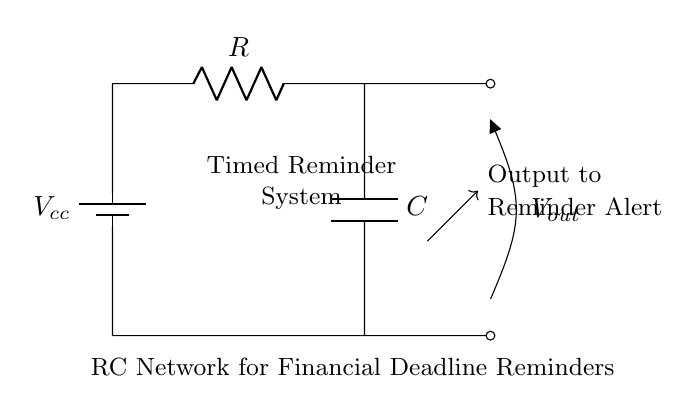What is the function of the capacitor in this circuit? The capacitor stores charge and affects the timing of the reminder system. It charges through the resistor and discharges to generate an output signal after a certain time delay.
Answer: timing What type of circuit is shown here? The circuit is a series circuit, as all components (battery, resistor, and capacitor) are connected in a single loop. Current flows through each component sequentially.
Answer: series What does the output voltage represent? The output voltage is the voltage across the capacitor, which changes as it charges and discharges, triggering the reminder alert when it reaches a certain level.
Answer: reminder alert voltage What is the purpose of the resistor in this circuit? The resistor limits the current flow to the capacitor, controlling the rate at which it charges and thus affecting the timing interval for the reminder system.
Answer: current limitation How is the reminder triggered in this circuit? The reminder is triggered when the voltage across the capacitor reaches a predetermined threshold, which is determined by the values of the resistor and capacitor.
Answer: voltage threshold What indicates the system is operational? The indicator is the presence of an output voltage signal that will alert the user when the reminder event occurs after the capacitor has charged sufficiently.
Answer: output voltage signal What component stores energy in the circuit? The capacitor is the component that stores electrical energy in the circuit, enabling the timed reminder functionality by releasing the energy at the right moment.
Answer: capacitor 